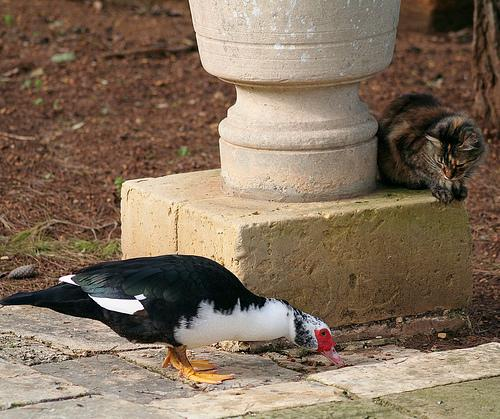How many animals are shown in the picture, and what are they doing? Two animals are shown in the picture: a cat watching a duck, and the duck appears to be looking for food. Provide an adjective describing the type of duck in the image and its dominant colors. The duck is a black and white duck with red markings around its eye and yellow feet. Based on the image, make an observation about the relationship between the cat and the duck. The cat appears curious or vigilant as it watches the duck, and both animals seem to coexist in the same environment. Describe the duck's eye and beak in the image. The duck has a red marking around its right eye and a red beak. Briefly describe the location where the cat and the duck are interacting. The cat and the duck are interacting near a concrete block and various stone pavers on the ground. What is the color of the cat and what is it doing in the image? The cat is dark brown with dark stripes, and it is watching the duck. Identify the primary interaction between two animals in the image. A dark brown cat with dark stripes is looking at a black, white, red, and yellow duck that appears to be searching for food. Count the number of animal feet (paws and webbed) visible in this image. Four animal feet are visible, two belonging to the cat and two to the duck. In a single sentence, capture the sentiment of the image. An intrigued cat closely observes a foraging duck in their shared urban environment. What objects are present in the image besides the cat and the duck, and what is their condition? There are light gray, dark gray, and tan cement pavers, a light gray cement pedestal, a part of a concrete plant pot, and a pine cone laying on the ground. What are the attributes of the bird and the cat in the image? Bird: black, white, red, and yellow feathers, red beak, orange feet. Cat: dark brown, dark stripes, sitting on a concrete block. What role does the bright pink ball near the stone blocks serve in this narrative? The contrast in colors seems striking. No, it's not mentioned in the image. Identify the emotions present in the image. Curiosity, hunger. Read any text visible in the image. There is no text visible in the image. Evaluate the quality of the image. The image is of high quality with clear objects and well-defined details. List any anomalies or unusual objects in the image. Pine cone laying on the ground. Which part of the bird has dark green feathers and where are they located? Dark green feathers are on bird's wing, located at X:68 Y:250 with a width of 128 and height of 128. What is the position of the cat looking at the bird and its size? The cat looking at the bird is at position X:0 Y:60 with a width of 499 and height of 499. Besides the bird and the concrete blocks, what is another object near the cat and its attributes? Decorative urn next to the cat with a base of X:210 Y:86 Width:172 Height:172. Explain the interaction between the cat and the bird in the image. The cat is watching the hungry bird, which is looking for food near the concrete blocks. Describe the cat in the image. The cat is dark brown with dark stripes and is sitting on a concrete block, watching the bird. What type of bird is present in the image? A black, white, red, and yellow duck. Segment and label each object in the image. Cat, bird, duck, concrete blocks, decorative urn, red marking around duck's eye, orange duck feet, stone blocks, cement pedestal, and pine cone. What objects are on the ground and what part of a cat is near them? There are stone blocks near the bird on the ground, and the cat's paws are near them at X:422 Y:183 Width:51 Height:51. Which objects can be seen next to the orange duck feet and what are their coordinates? Light gray cement pedestal at X:118 Y:162 Width:358 Height:358, dark gray rectangle paver at X:26 Y:345 Width:179 Height:179, and light gray rectangular paver at X:310 Y:339 Width:187 Height:187. Describe the location and appearance of the red marking around the eye of a duck. The red marking is located at X:310 Y:326 with a width of 27 and height of 27. 